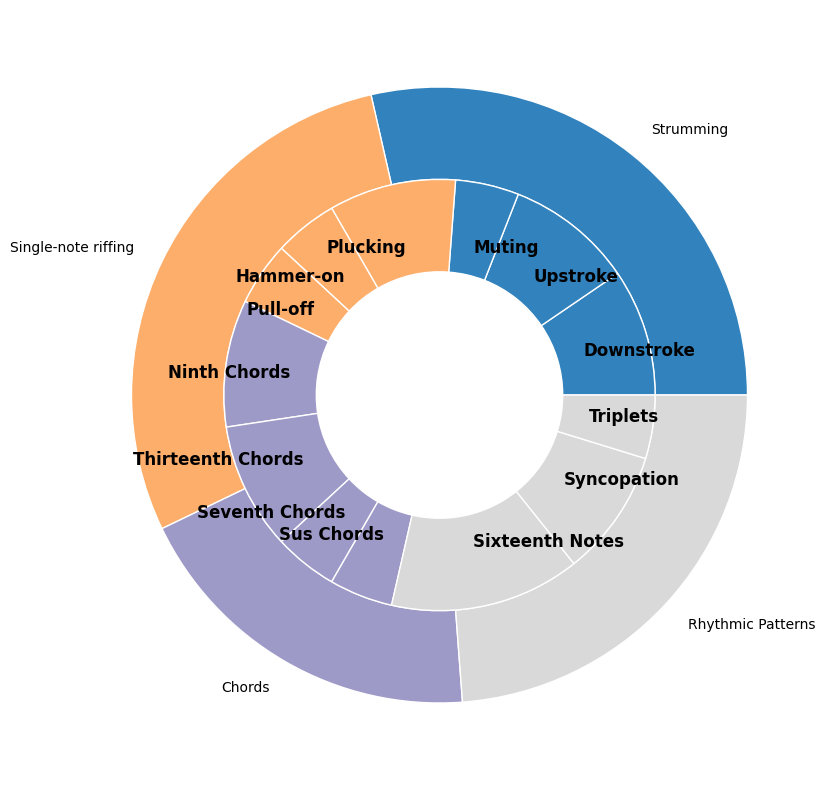Which sub-technique has the largest percentage? Among all the sub-techniques presented in the inner circle, "Sixteenth Notes" under "Rhythmic Patterns" covers the largest area, indicating the highest percentage.
Answer: Sixteenth Notes What is the total percentage of Strumming techniques? Sum the percentages of the sub-techniques under Strumming: Downstroke (10%), Upstroke (10%), and Muting (5%). 10% + 10% + 5% = 25%
Answer: 25% Which technique has a sub-technique with the lowest percentage? By examining the inner circle, we can observe that several sub-techniques have a 5% contribution, including "Muting" under Strumming, "Hammer-on" and "Pull-off" under Single-note riffing, "Seventh Chords" and "Sus Chords" under Chords, and "Triplets" under Rhythmic Patterns. These are equally lowest. Choose any one of them.
Answer: Rhythmic Patterns (example) Between "Ninth Chords" and "Plucking," which one has a higher percentage? "Ninth Chords" under Chords and "Plucking" under Single-note riffing both have their dedicated wedges visible in the inner circle. "Ninth Chords" displays a 10% area, while "Plucking" also shows a 10% area. Therefore, their percentages are equal.
Answer: Equal Is the area representing "Chords" larger than that of "Single-note riffing"? The outer circle shows the total percentage for each technique. By comparing the two sectors, "Chords" has a combined percentage of 30% (10% + 10% + 5% + 5%), and "Single-note riffing" has 20% (10% + 5% + 5%). Thus, "Chords" has a larger area.
Answer: Yes How many sub-techniques fall under "Rhythmic Patterns," and what is their combined percentage? There are three sub-techniques under "Rhythmic Patterns": "Sixteenth Notes," "Syncopation," and "Triplets." Adding their percentages gives us 15% + 10% + 5% = 30%.
Answer: 3, 30% What proportion of the entire chart does "Muting" make up? "Muting" is a sub-technique under Strumming with a specified percentage of 5%.
Answer: 5% Are there more sub-techniques under "Strumming" or "Chords"? By counting the sectors in the inner circle, "Strumming" has three sub-techniques ("Downstroke," "Upstroke," "Muting"), whereas "Chords" has four sub-techniques ("Ninth Chords," "Thirteenth Chords," "Seventh Chords," "Sus Chords"). Therefore, "Chords" has more sub-techniques.
Answer: Chords Compare the total percentage of "Upstroke" and "Downstroke" to "Sixteenth Notes." Which is higher? Add the percentages of "Upstroke" (10%) and "Downstroke" (10%) to get 20%. Compare this to "Sixteenth Notes" which has 15%. Therefore, 20% for "Upstroke" and "Downstroke" is greater than 15% for "Sixteenth Notes."
Answer: Upstroke and Downstroke What is the least represented technique, and what is its total percentage? By observing the outer circle, "Single-note riffing" has the smallest combined percentage of 20% (10% + 5% + 5%) among all the techniques presented.
Answer: Single-note riffing, 20% 